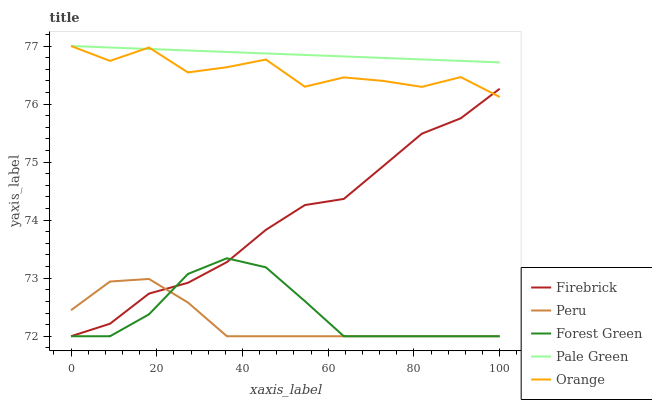Does Peru have the minimum area under the curve?
Answer yes or no. Yes. Does Pale Green have the maximum area under the curve?
Answer yes or no. Yes. Does Firebrick have the minimum area under the curve?
Answer yes or no. No. Does Firebrick have the maximum area under the curve?
Answer yes or no. No. Is Pale Green the smoothest?
Answer yes or no. Yes. Is Orange the roughest?
Answer yes or no. Yes. Is Firebrick the smoothest?
Answer yes or no. No. Is Firebrick the roughest?
Answer yes or no. No. Does Firebrick have the lowest value?
Answer yes or no. Yes. Does Pale Green have the lowest value?
Answer yes or no. No. Does Pale Green have the highest value?
Answer yes or no. Yes. Does Firebrick have the highest value?
Answer yes or no. No. Is Forest Green less than Orange?
Answer yes or no. Yes. Is Orange greater than Peru?
Answer yes or no. Yes. Does Orange intersect Firebrick?
Answer yes or no. Yes. Is Orange less than Firebrick?
Answer yes or no. No. Is Orange greater than Firebrick?
Answer yes or no. No. Does Forest Green intersect Orange?
Answer yes or no. No. 